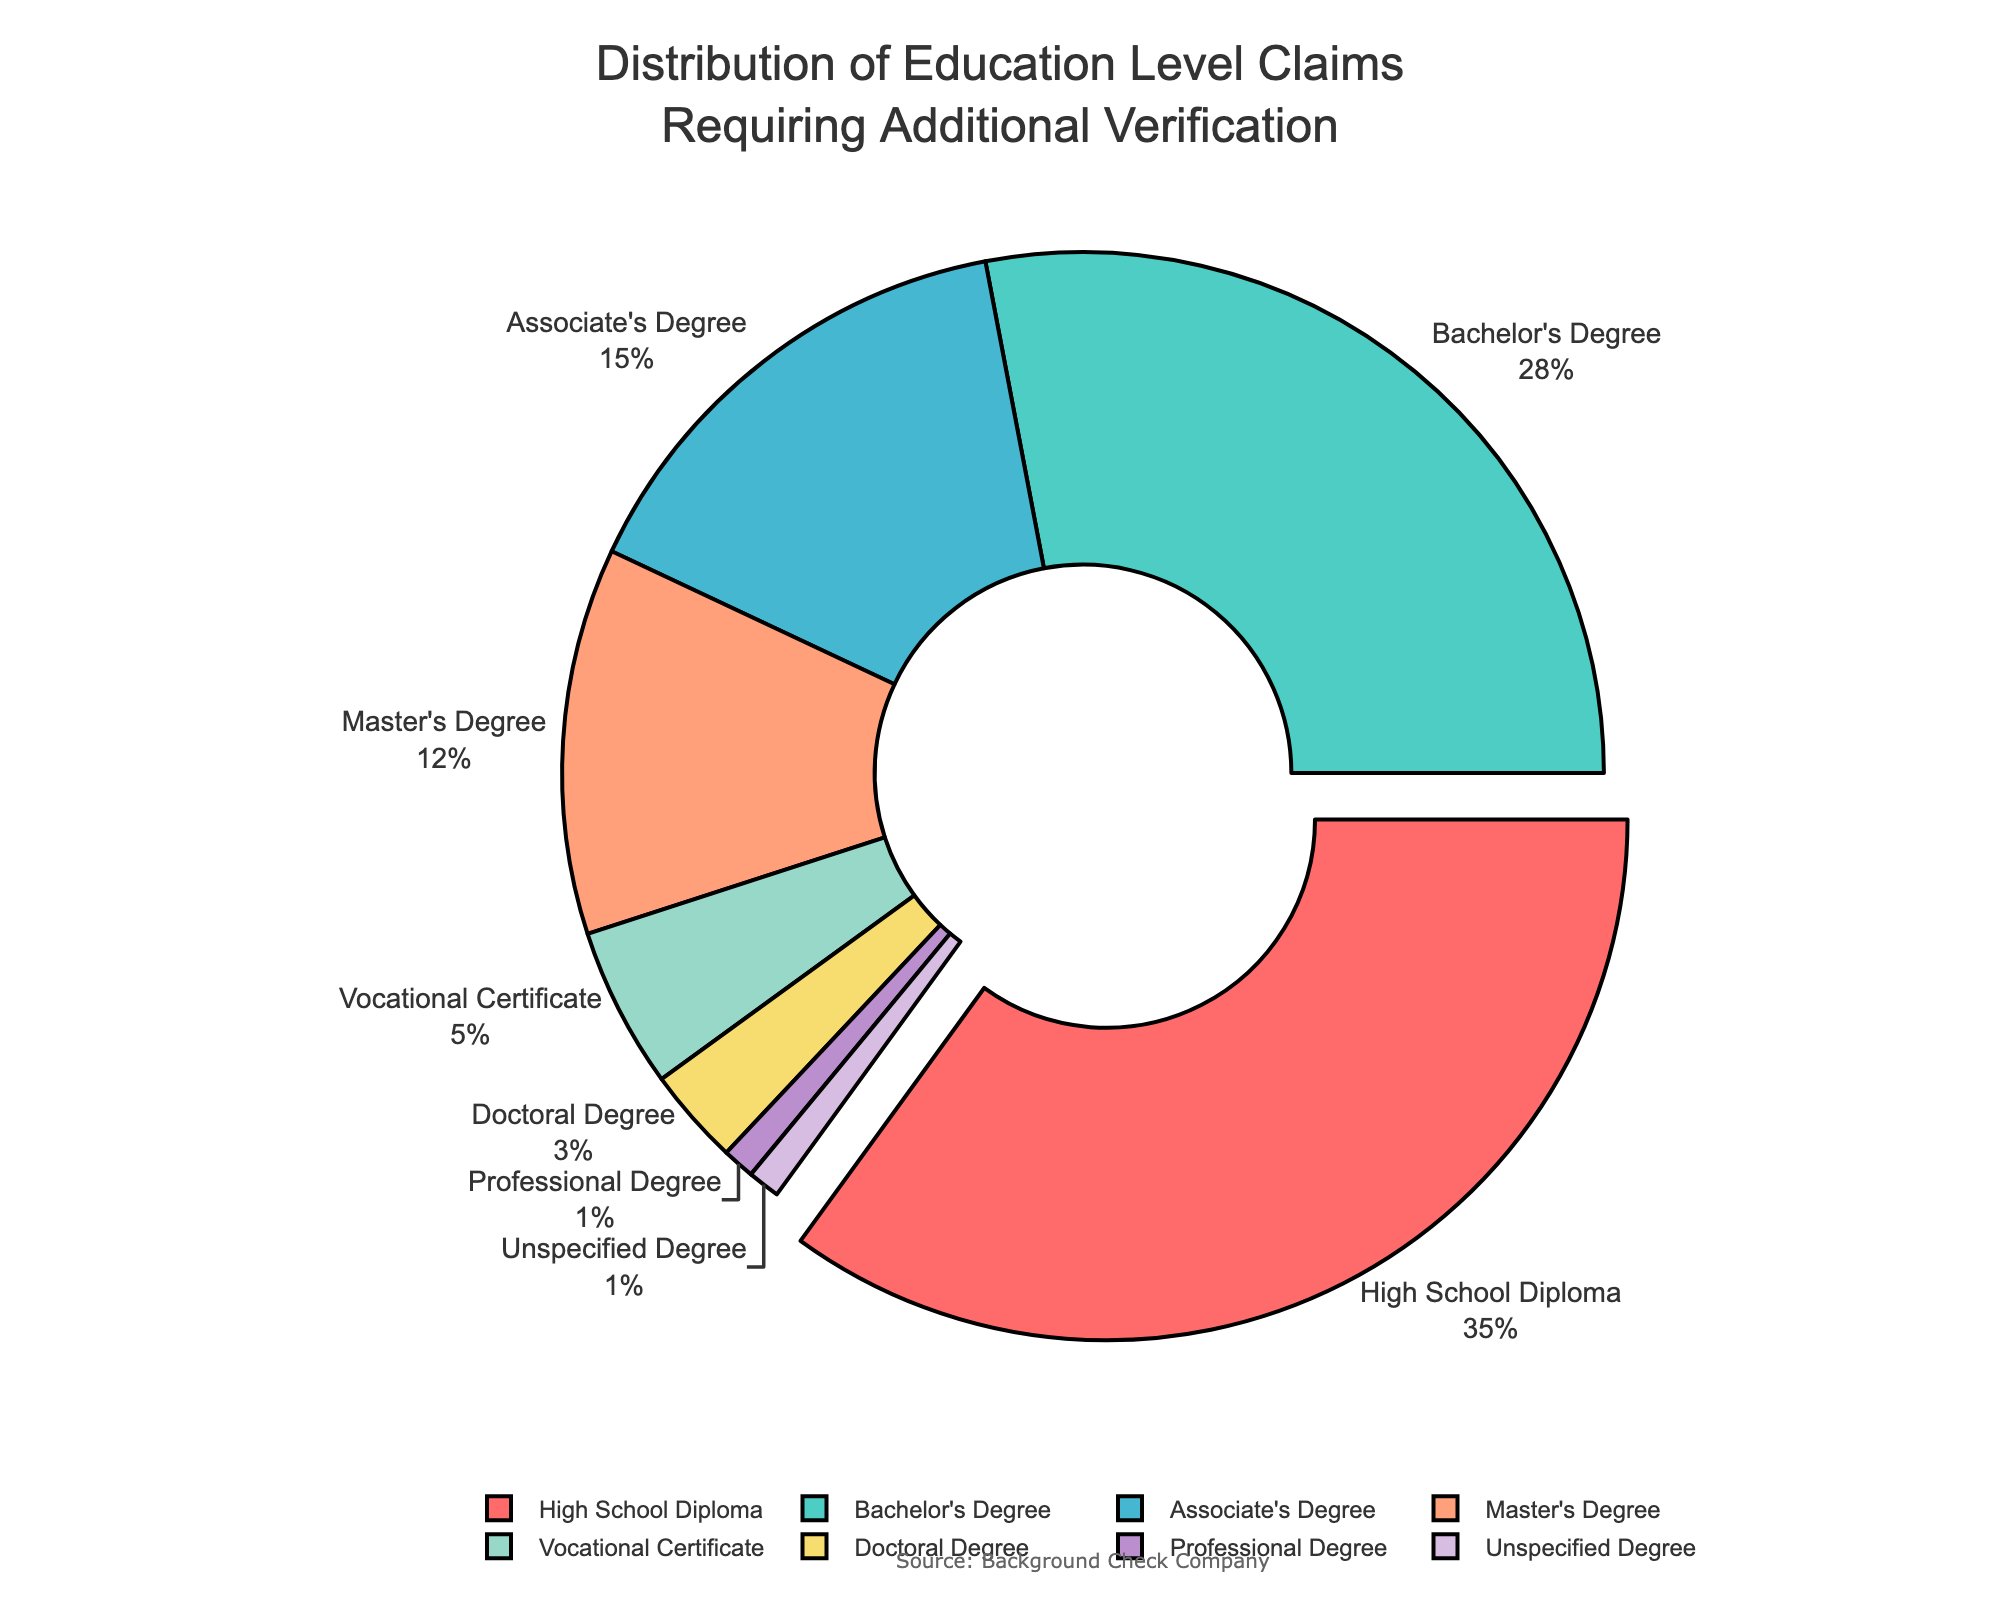Which education level has the highest percentage of claims requiring additional verification? The sector with the largest slice is visually distinguishable by both size and pull-out effect. Observing the pie chart, "High School Diploma" has the slice pulled out, indicating it has the highest percentage.
Answer: High School Diploma Which education levels have the same percentage of claims requiring additional verification? By examining the size and labels of each slice, "Professional Degree" and "Unspecified Degree" each occupy 1% of the pie chart, making their slices equal in percentage.
Answer: Professional Degree and Unspecified Degree What is the total percentage of claims requiring additional verification for Bachelor's and Master's Degrees combined? Identify the slices for Bachelor's Degree and Master's Degree, then add their percentages together: 28% + 12% = 40%.
Answer: 40% What is the difference in percentage between the education level with the highest claims and the one with the lowest claims? The "High School Diploma" slice has the highest percentage (35%), and both "Professional Degree" and "Unspecified Degree" have the lowest (1%). Calculate the difference: 35% - 1% = 34%.
Answer: 34% Which color represents the Bachelor's Degree? By looking at the legend in the pie chart, the color corresponding to "Bachelor's Degree" is light green.
Answer: Light green Which education level is represented by the smallest slice and what is the percentage? At the smallest segment by size in the pie, observing the slice labels shows that both "Professional Degree" and "Unspecified Degree" each occupy the smallest portion at 1%.
Answer: Professional Degree and Unspecified Degree, 1% What percentage of claims does Vocational Certificate make up? Find the slice labeled "Vocational Certificate" on the pie chart, which visually shows it comprises 5%.
Answer: 5% How much more or less is the percentage of claims for Associate's Degree compared to Master's Degree? Observe the slices for both Associate's and Master's Degrees, with figures of 15% and 12% respectively. The difference is 15% - 12% = 3%.
Answer: 3% more What is the combined percentage of claims for education levels other than High School Diploma? Exclude "High School Diploma" (35%) and sum up the percentages for the other levels: 28% + 15% + 12% + 5% + 3% + 1% + 1% = 65%.
Answer: 65% Which slice is colored in red and what education level does it represent? Refer to the pie chart and match the color red to the appropriate slice, which represents "High School Diploma".
Answer: High School Diploma 